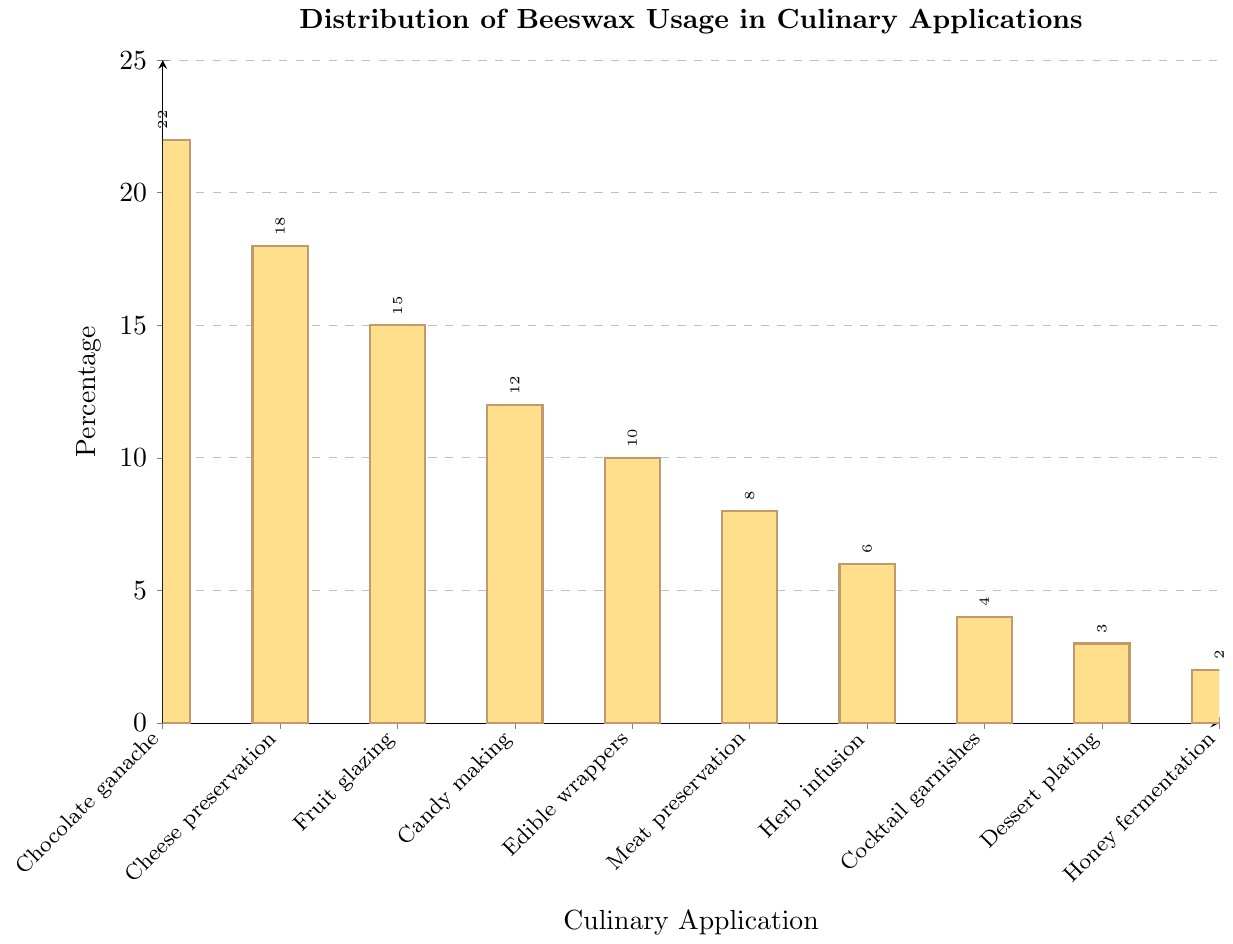Which culinary application uses the most beeswax? The bar for 'Chocolate ganache coating' is the highest on the plot.
Answer: Chocolate ganache coating What's the percentage difference between Chocolate ganache coating and Cheese rind preservation? The bar for 'Chocolate ganache coating' is at 22% and 'Cheese rind preservation' is at 18%. The difference is 22% - 18% = 4%.
Answer: 4% Which culinary applications use beeswax less than 10%? From the plot, the applications with bars below the 10% mark are Meat preservation (8%), Herb and spice infusion (6%), Cocktail garnishes (4%), Dessert plating (3%), and Honey fermentation (2%).
Answer: Meat preservation, Herb and spice infusion, Cocktail garnishes, Dessert plating, Honey fermentation What is the total percentage of beeswax usage for Meat preservation, Herb and spice infusion, and Dessert plating combined? The bars for Meat preservation, Herb and spice infusion, and Dessert plating are at 8%, 6%, and 3% respectively. The total percentage is 8% + 6% + 3% = 17%.
Answer: 17% How many applications use beeswax in percentage ranges between 10% and 15%? The applications within the range are 'Fruit glazing' (15%), 'Candy making' (12%), and 'Edible food wrappers' (10%). There are 3 data points in this range.
Answer: 3 Which application has close to half the usage as Chocolate ganache coating? Chocolate ganache coating is at 22%. Half of this is 11%. 'Candy making' at 12% is the closest application to this value.
Answer: Candy making Considering the combined percentage of the two least common usages of beeswax, by what margin is it less than the percentage of Cheese rind preservation? The two least common usages are 'Honey fermentation' (2%) and 'Dessert plating' (3%). Their combined percentage is 5%. The Cheese rind preservation is 18%. The difference is 18% - 5% = 13%.
Answer: 13% Which bar is the shortest and what percentage does it represent? The shortest bar corresponds to 'Honey fermentation' at 2%.
Answer: Honey fermentation, 2% What is the sum of the percentages for the top three applications? The percentages for the top three applications, 'Chocolate ganache coating' (22%), 'Cheese rind preservation' (18%), and 'Fruit glazing' (15%), are summed as 22% + 18% + 15% = 55%.
Answer: 55% Is 'Cocktail garnishes' more or less used than 'Edible food wrappers' and by how much? 'Cocktail garnishes' is at 4% while 'Edible food wrappers' is at 10%. The difference is 10% - 4% = 6%.
Answer: Less, 6% 